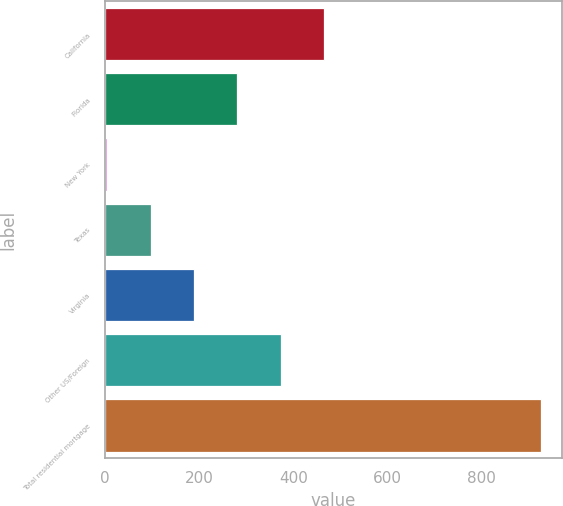<chart> <loc_0><loc_0><loc_500><loc_500><bar_chart><fcel>California<fcel>Florida<fcel>New York<fcel>Texas<fcel>Virginia<fcel>Other US/Foreign<fcel>Total residential mortgage<nl><fcel>465<fcel>281<fcel>5<fcel>97<fcel>189<fcel>373<fcel>925<nl></chart> 